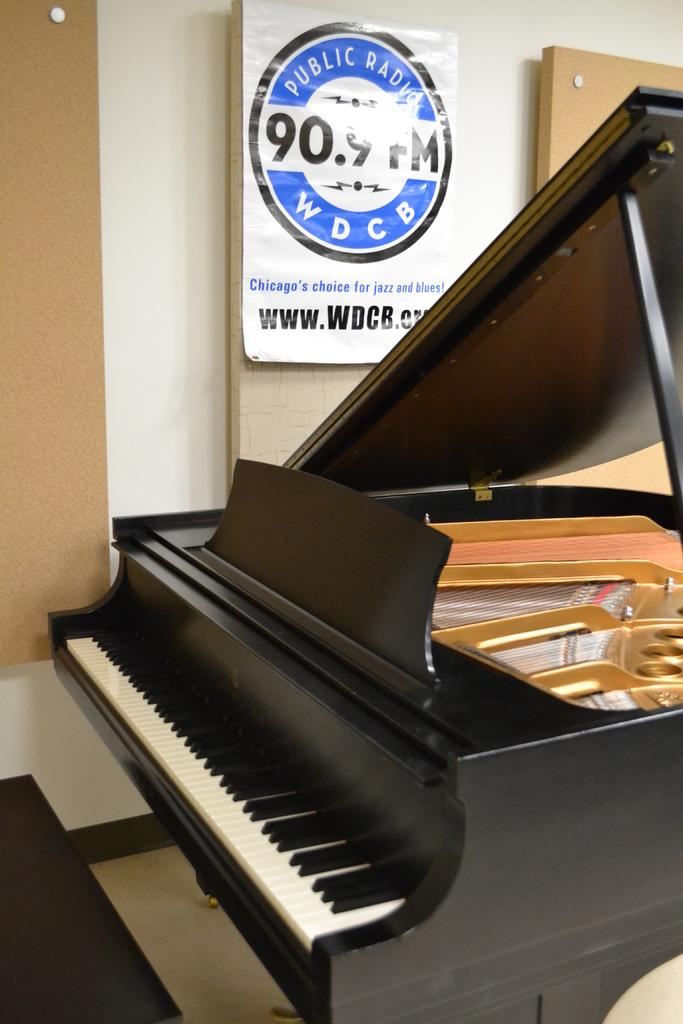What is on the wall in the image? There is a poster on the wall. What is depicted on the poster? The poster features a piano keyboard. What colors are the keys on the piano keyboard? The piano keyboard has black keys and white keys. What type of bread is being used to play the piano keyboard in the image? There is no bread present in the image, and the piano keyboard is not being played with any type of bread. 